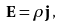Convert formula to latex. <formula><loc_0><loc_0><loc_500><loc_500>\mathbf E = \rho \mathbf j \, ,</formula> 